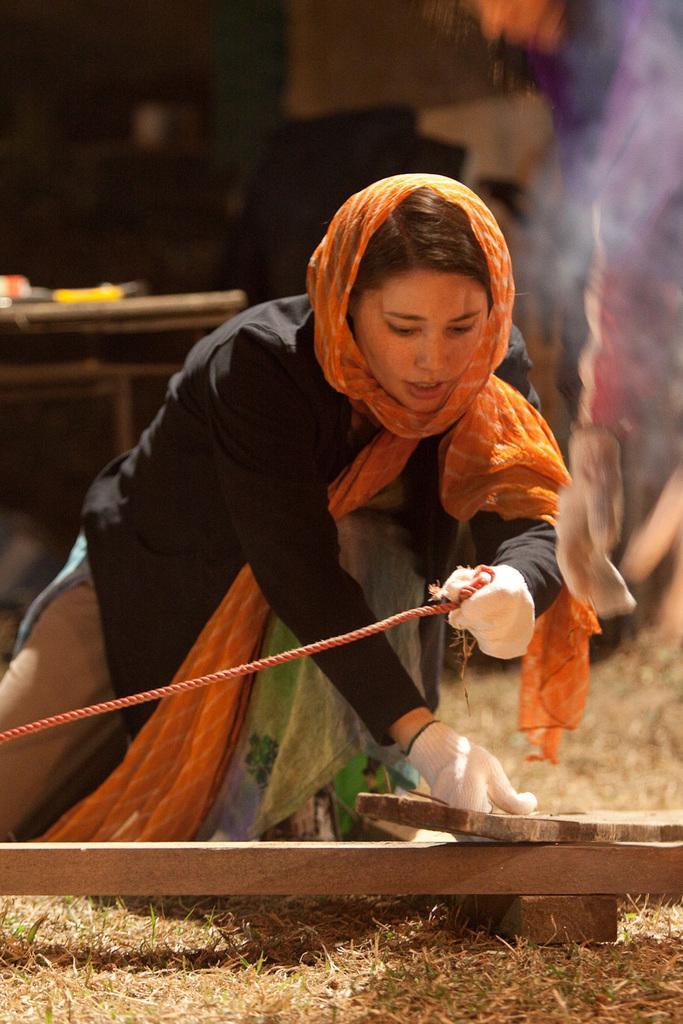Could you give a brief overview of what you see in this image? In this image in the front there is a woman holding a rope and wood in her hand. In the background there is a table and on the table there are objects. 